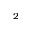Convert formula to latex. <formula><loc_0><loc_0><loc_500><loc_500>_ { 2 }</formula> 